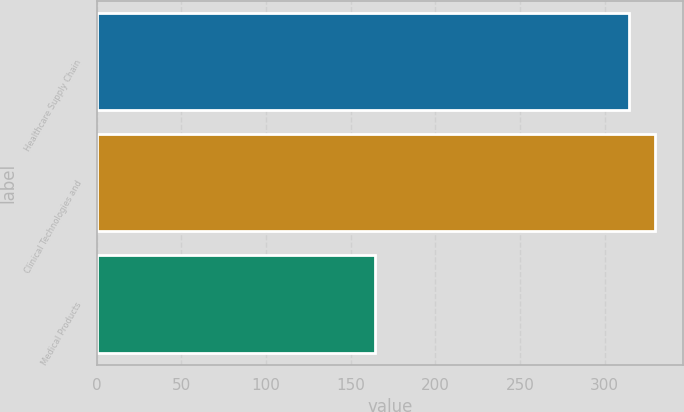Convert chart. <chart><loc_0><loc_0><loc_500><loc_500><bar_chart><fcel>Healthcare Supply Chain<fcel>Clinical Technologies and<fcel>Medical Products<nl><fcel>314.5<fcel>330.08<fcel>164.5<nl></chart> 